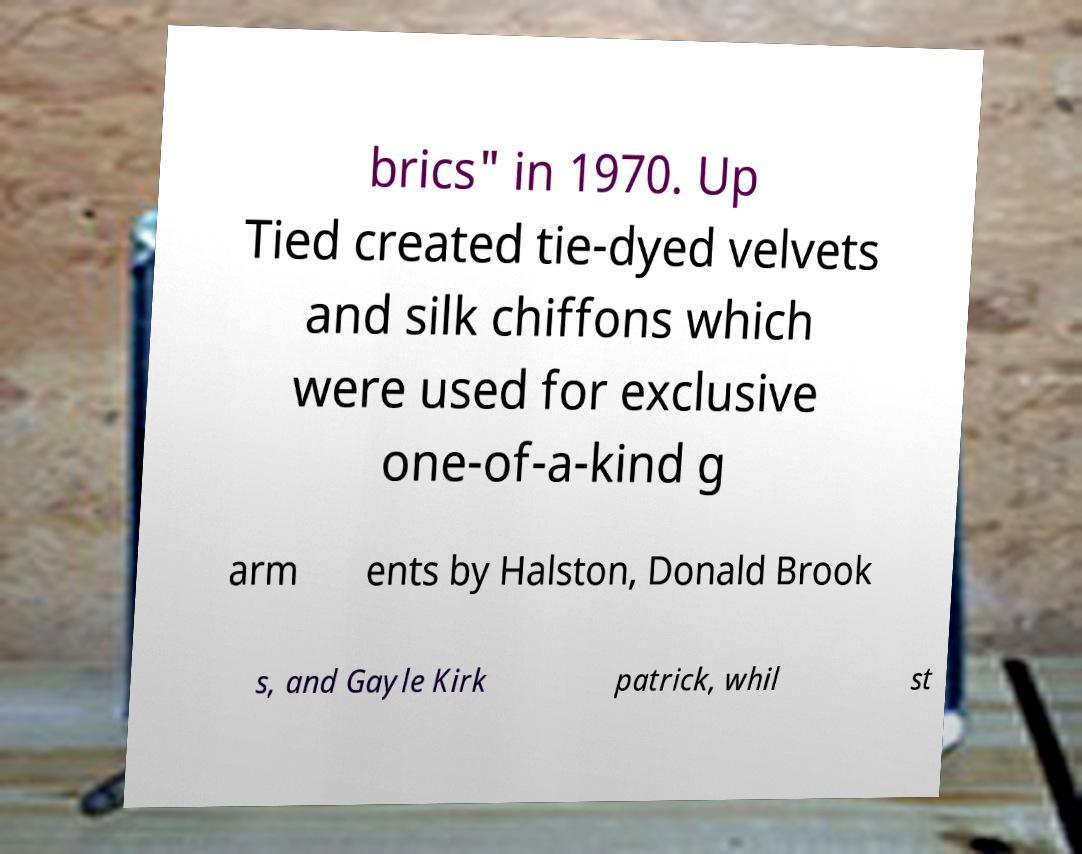Can you read and provide the text displayed in the image?This photo seems to have some interesting text. Can you extract and type it out for me? brics" in 1970. Up Tied created tie-dyed velvets and silk chiffons which were used for exclusive one-of-a-kind g arm ents by Halston, Donald Brook s, and Gayle Kirk patrick, whil st 